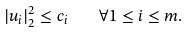Convert formula to latex. <formula><loc_0><loc_0><loc_500><loc_500>| u _ { i } | ^ { 2 } _ { 2 } \leq c _ { i } \quad \forall 1 \leq i \leq m .</formula> 